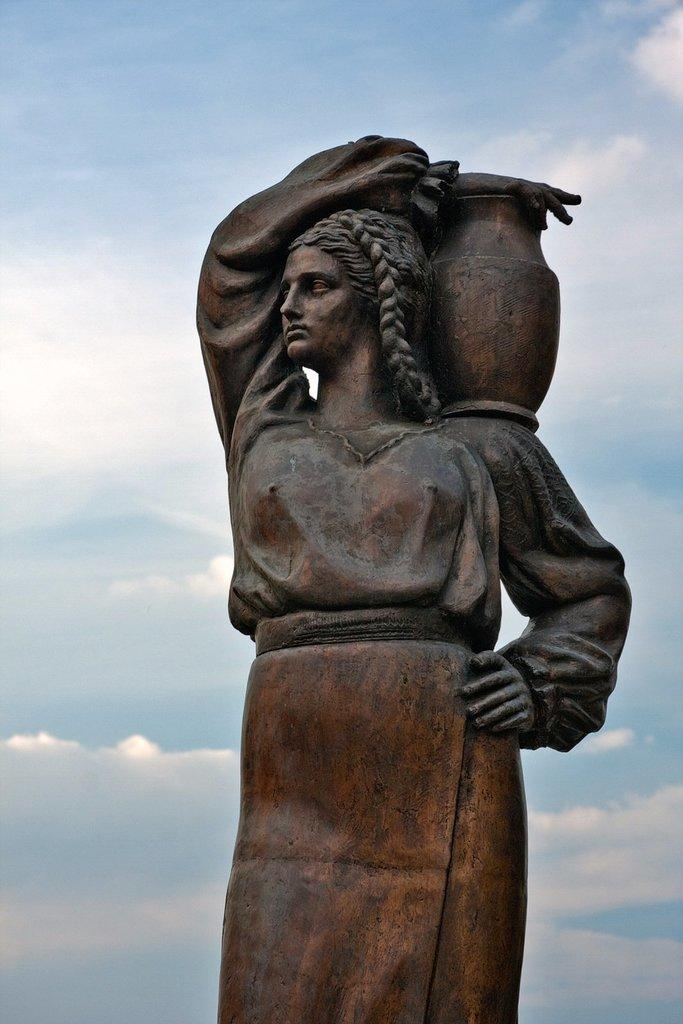What is the main subject in the picture? There is a statue in the picture. Can you describe the sky in the image? The sky is blue and cloudy. How does the stick control the account in the image? There is no stick or account present in the image; it only features a statue and a blue, cloudy sky. 